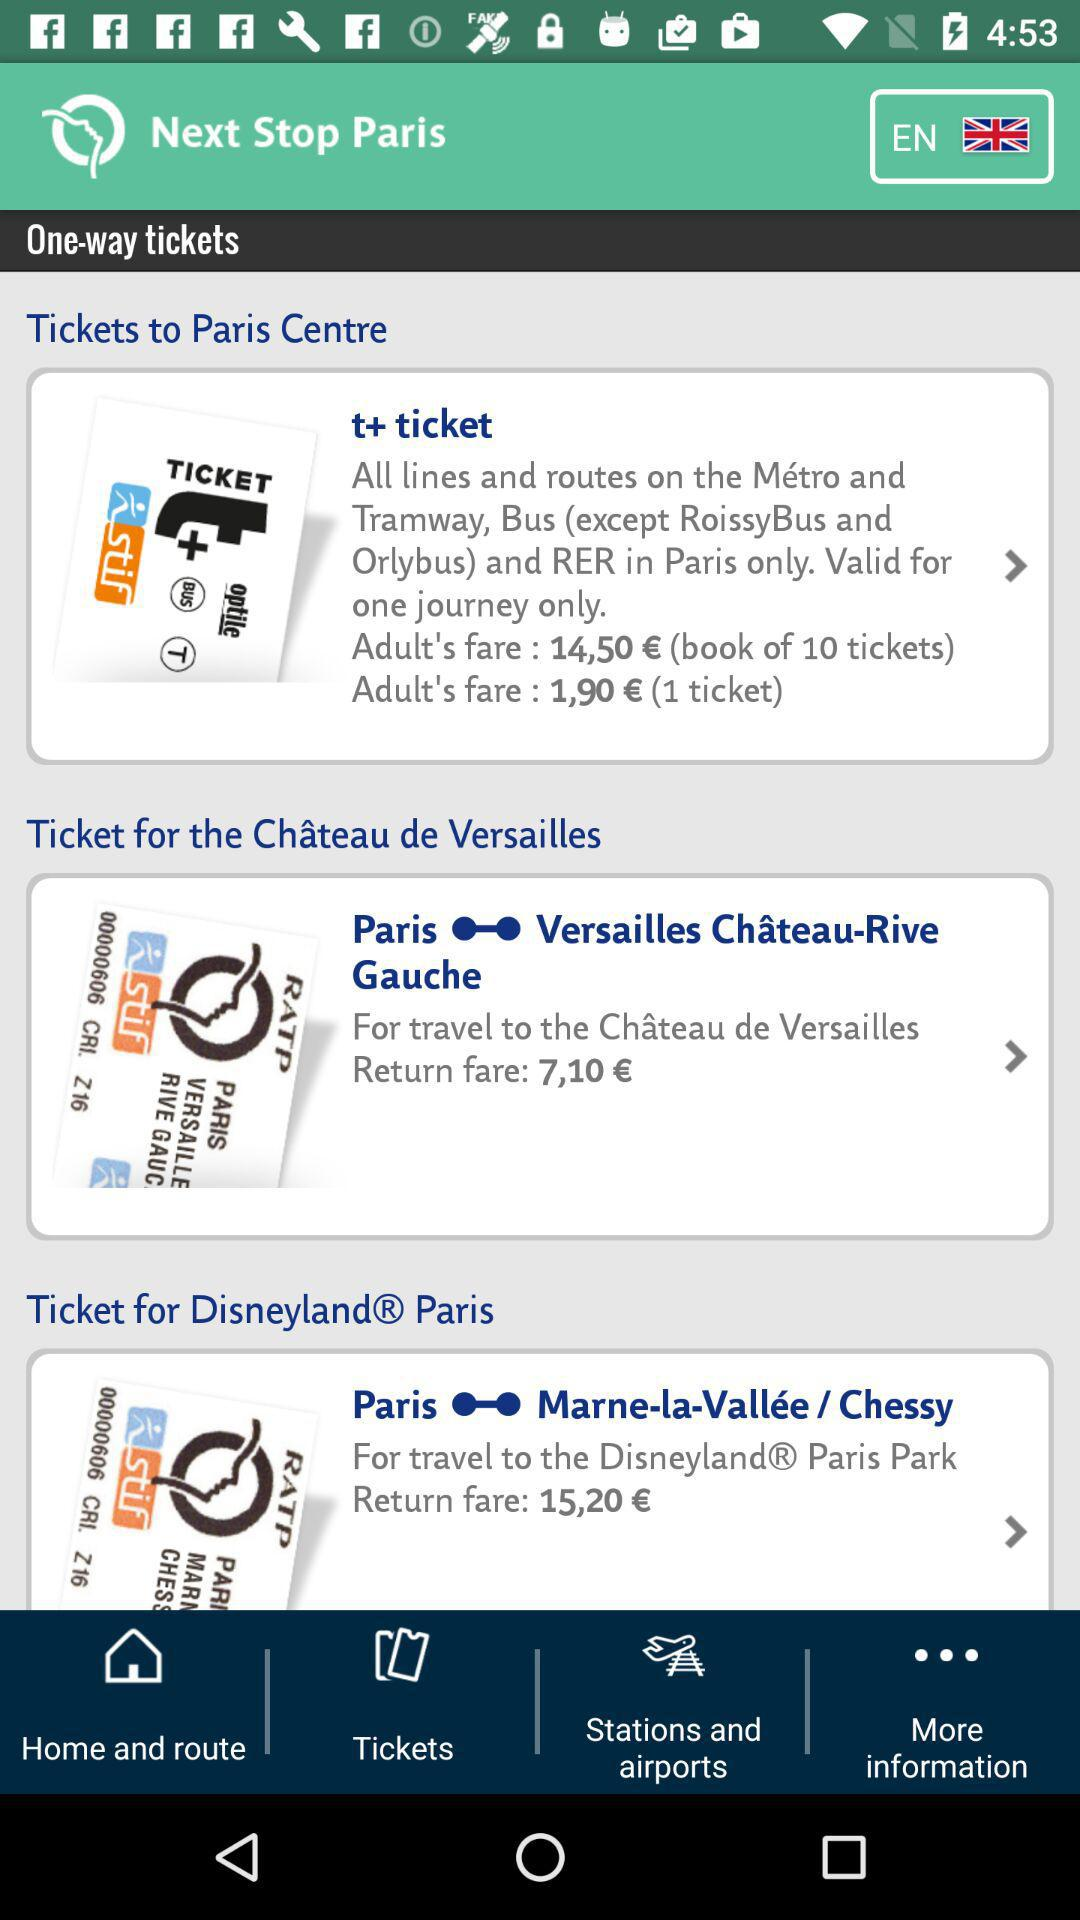What is the total fare to book 10 tickets for adults in "t+ticket"? The total fare to book 10 tickets for adults in "t+ticket" is €14,50. 